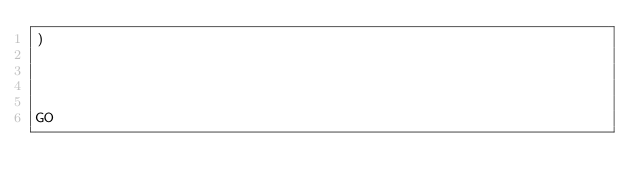Convert code to text. <code><loc_0><loc_0><loc_500><loc_500><_SQL_>)




GO
</code> 